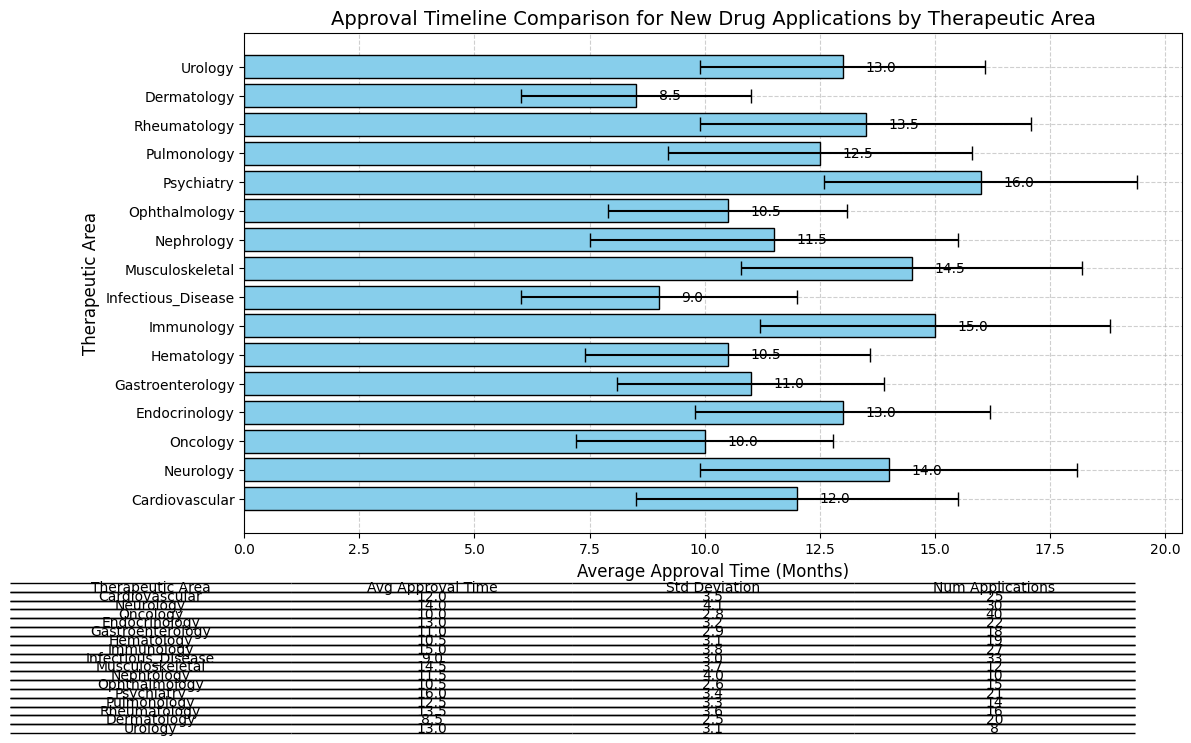What's the average approval time for drugs in the Dermatology therapeutic area? The table shows the average approval time for each therapeutic area. For Dermatology, it is specified directly in the table.
Answer: 8.5 months Which two therapeutic areas have the same average approval time, and what is their average approval time? From the table, Endocrinology and Urology both have an average approval time of 13 months.
Answer: Endocrinology and Urology, 13 months Between Oncology and Neurology, which therapeutic area has a shorter average approval time, and by how much? The average approval time for Oncology is 10 months, while for Neurology it is 14 months. The difference is 14 - 10 = 4 months.
Answer: Oncology, 4 months What is the therapeutic area with the smallest standard deviation in approval time? The table shows the standard deviations for each therapeutic area. Dermatology has the smallest value at 2.5 months.
Answer: Dermatology How many more new drug applications are there in Psychiatry compared to Musculoskeletal? Psychiatry has 21 applications, and Musculoskeletal has 12. The difference is 21 - 12 = 9 applications.
Answer: 9 applications What is the total number of new drug applications in Cardiovascular and Gastroenterology combined? Cardiovascular has 25 applications, and Gastroenterology has 18. The total is 25 + 18 = 43 applications.
Answer: 43 applications Which therapeutic area has the longest average approval time, and what is that time? According to the table, Psychiatry has the longest average approval time at 16 months.
Answer: Psychiatry, 16 months What is the average approval time for therapeutic areas with less than 15 applications? Therapeutic areas with less than 15 applications are Musculoskeletal, Nephrology, Ophthalmology, Pulmonology, and Urology. Their average approval times are 14.5, 11.5, 10.5, 12.5, and 13 months respectively. The total is 14.5 + 11.5 + 10.5 + 12.5 + 13 = 62 months. The average for 5 areas is 62 / 5 = 12.4 months.
Answer: 12.4 months How does the average approval time of Infectious Disease compare to Immunology? The average approval time for Infectious Disease is 9 months, and for Immunology, it is 15 months. Comparing the two, Immunology takes longer by 15 - 9 = 6 months.
Answer: Infectious Disease is 6 months shorter Which therapeutic areas have an average approval time less than 11 months? By checking the table, Oncology (10 months), Gastroenterology (11 months), Hematology (10.5 months), Infectious Disease (9 months), Ophthalmology (10.5 months), and Dermatology (8.5 months) all have average approval times less than 11 months.
Answer: Oncology, Hematology, Infectious Disease, Ophthalmology, Dermatology 